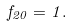<formula> <loc_0><loc_0><loc_500><loc_500>f _ { 2 0 } = 1 .</formula> 